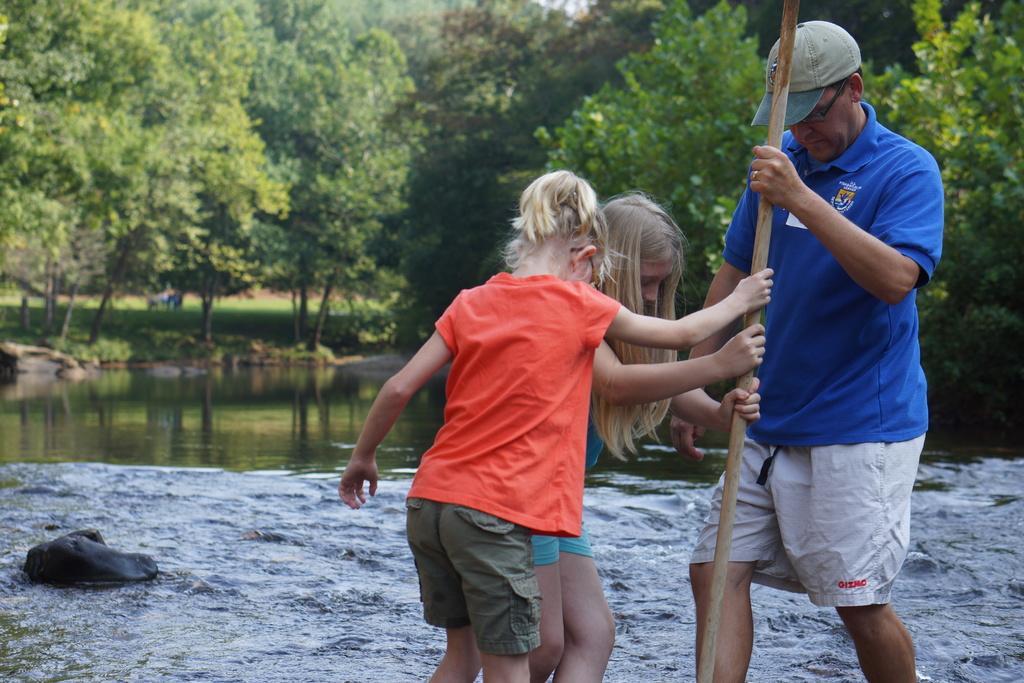How would you summarize this image in a sentence or two? There is a man and two children holding a stick. Man is wearing a cap and specs. In the background there is water, rocks and trees. 